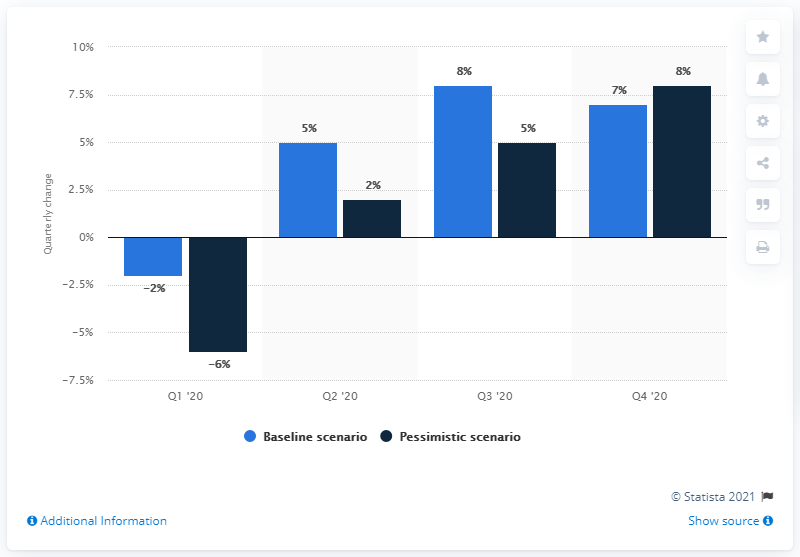Draw attention to some important aspects in this diagram. The difference between the baseline and the pessimistic scenario is least in the fourth quarter of 2020. The graph shows a negative scenario in the first quarter of 2020. 